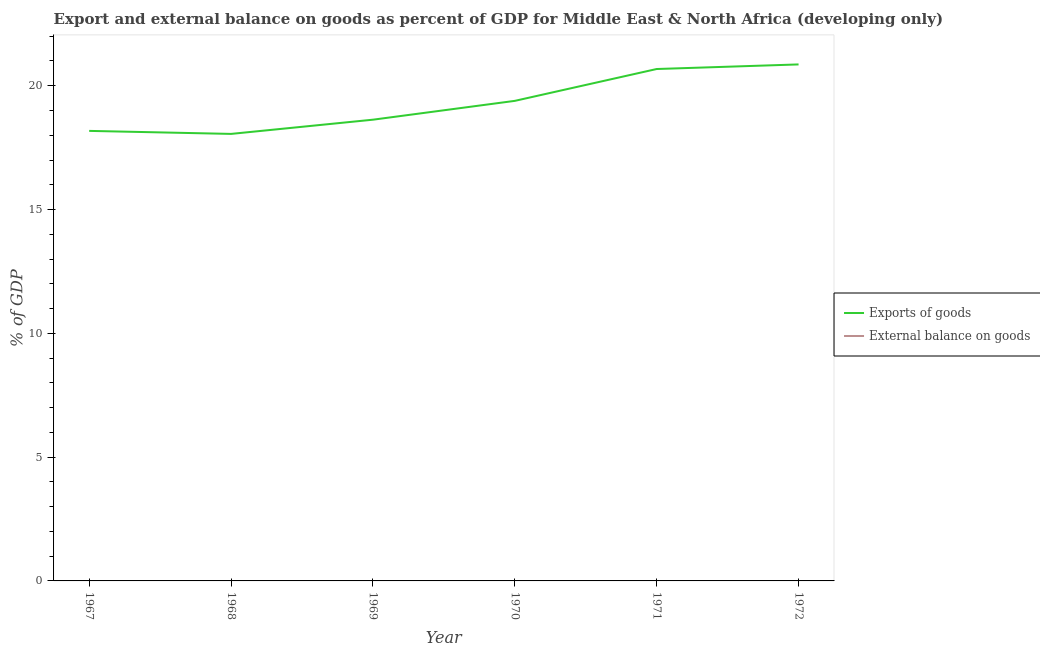How many different coloured lines are there?
Your response must be concise. 1. Does the line corresponding to export of goods as percentage of gdp intersect with the line corresponding to external balance on goods as percentage of gdp?
Ensure brevity in your answer.  No. Across all years, what is the maximum export of goods as percentage of gdp?
Give a very brief answer. 20.86. What is the total export of goods as percentage of gdp in the graph?
Provide a short and direct response. 115.78. What is the difference between the export of goods as percentage of gdp in 1971 and that in 1972?
Your response must be concise. -0.19. What is the difference between the external balance on goods as percentage of gdp in 1967 and the export of goods as percentage of gdp in 1971?
Keep it short and to the point. -20.68. In how many years, is the export of goods as percentage of gdp greater than 10 %?
Your answer should be compact. 6. What is the ratio of the export of goods as percentage of gdp in 1967 to that in 1970?
Offer a very short reply. 0.94. Is the export of goods as percentage of gdp in 1970 less than that in 1971?
Give a very brief answer. Yes. What is the difference between the highest and the second highest export of goods as percentage of gdp?
Provide a short and direct response. 0.19. What is the difference between the highest and the lowest export of goods as percentage of gdp?
Provide a short and direct response. 2.81. Is the sum of the export of goods as percentage of gdp in 1969 and 1972 greater than the maximum external balance on goods as percentage of gdp across all years?
Your answer should be compact. Yes. Is the external balance on goods as percentage of gdp strictly greater than the export of goods as percentage of gdp over the years?
Provide a short and direct response. No. Does the graph contain any zero values?
Provide a short and direct response. Yes. Where does the legend appear in the graph?
Provide a short and direct response. Center right. What is the title of the graph?
Provide a short and direct response. Export and external balance on goods as percent of GDP for Middle East & North Africa (developing only). What is the label or title of the Y-axis?
Your answer should be very brief. % of GDP. What is the % of GDP in Exports of goods in 1967?
Your answer should be compact. 18.18. What is the % of GDP in External balance on goods in 1967?
Keep it short and to the point. 0. What is the % of GDP of Exports of goods in 1968?
Offer a very short reply. 18.05. What is the % of GDP of External balance on goods in 1968?
Make the answer very short. 0. What is the % of GDP of Exports of goods in 1969?
Ensure brevity in your answer.  18.63. What is the % of GDP in External balance on goods in 1969?
Keep it short and to the point. 0. What is the % of GDP in Exports of goods in 1970?
Make the answer very short. 19.39. What is the % of GDP in Exports of goods in 1971?
Your answer should be compact. 20.68. What is the % of GDP of External balance on goods in 1971?
Offer a terse response. 0. What is the % of GDP of Exports of goods in 1972?
Your answer should be compact. 20.86. What is the % of GDP in External balance on goods in 1972?
Provide a short and direct response. 0. Across all years, what is the maximum % of GDP in Exports of goods?
Ensure brevity in your answer.  20.86. Across all years, what is the minimum % of GDP in Exports of goods?
Your answer should be compact. 18.05. What is the total % of GDP in Exports of goods in the graph?
Make the answer very short. 115.78. What is the total % of GDP in External balance on goods in the graph?
Your answer should be very brief. 0. What is the difference between the % of GDP in Exports of goods in 1967 and that in 1968?
Your answer should be compact. 0.12. What is the difference between the % of GDP of Exports of goods in 1967 and that in 1969?
Your response must be concise. -0.45. What is the difference between the % of GDP in Exports of goods in 1967 and that in 1970?
Your response must be concise. -1.21. What is the difference between the % of GDP of Exports of goods in 1967 and that in 1971?
Provide a succinct answer. -2.5. What is the difference between the % of GDP in Exports of goods in 1967 and that in 1972?
Give a very brief answer. -2.68. What is the difference between the % of GDP in Exports of goods in 1968 and that in 1969?
Your answer should be very brief. -0.57. What is the difference between the % of GDP in Exports of goods in 1968 and that in 1970?
Make the answer very short. -1.33. What is the difference between the % of GDP in Exports of goods in 1968 and that in 1971?
Your response must be concise. -2.62. What is the difference between the % of GDP of Exports of goods in 1968 and that in 1972?
Provide a short and direct response. -2.81. What is the difference between the % of GDP of Exports of goods in 1969 and that in 1970?
Offer a very short reply. -0.76. What is the difference between the % of GDP of Exports of goods in 1969 and that in 1971?
Keep it short and to the point. -2.05. What is the difference between the % of GDP in Exports of goods in 1969 and that in 1972?
Provide a succinct answer. -2.23. What is the difference between the % of GDP of Exports of goods in 1970 and that in 1971?
Provide a short and direct response. -1.29. What is the difference between the % of GDP of Exports of goods in 1970 and that in 1972?
Keep it short and to the point. -1.47. What is the difference between the % of GDP in Exports of goods in 1971 and that in 1972?
Your answer should be compact. -0.19. What is the average % of GDP of Exports of goods per year?
Give a very brief answer. 19.3. What is the ratio of the % of GDP in Exports of goods in 1967 to that in 1969?
Your answer should be compact. 0.98. What is the ratio of the % of GDP of Exports of goods in 1967 to that in 1971?
Keep it short and to the point. 0.88. What is the ratio of the % of GDP of Exports of goods in 1967 to that in 1972?
Provide a succinct answer. 0.87. What is the ratio of the % of GDP in Exports of goods in 1968 to that in 1969?
Your answer should be compact. 0.97. What is the ratio of the % of GDP in Exports of goods in 1968 to that in 1970?
Provide a succinct answer. 0.93. What is the ratio of the % of GDP in Exports of goods in 1968 to that in 1971?
Your answer should be compact. 0.87. What is the ratio of the % of GDP in Exports of goods in 1968 to that in 1972?
Keep it short and to the point. 0.87. What is the ratio of the % of GDP in Exports of goods in 1969 to that in 1970?
Your answer should be very brief. 0.96. What is the ratio of the % of GDP of Exports of goods in 1969 to that in 1971?
Provide a short and direct response. 0.9. What is the ratio of the % of GDP in Exports of goods in 1969 to that in 1972?
Provide a short and direct response. 0.89. What is the ratio of the % of GDP of Exports of goods in 1970 to that in 1971?
Ensure brevity in your answer.  0.94. What is the ratio of the % of GDP of Exports of goods in 1970 to that in 1972?
Offer a terse response. 0.93. What is the ratio of the % of GDP in Exports of goods in 1971 to that in 1972?
Keep it short and to the point. 0.99. What is the difference between the highest and the second highest % of GDP in Exports of goods?
Make the answer very short. 0.19. What is the difference between the highest and the lowest % of GDP of Exports of goods?
Your answer should be compact. 2.81. 